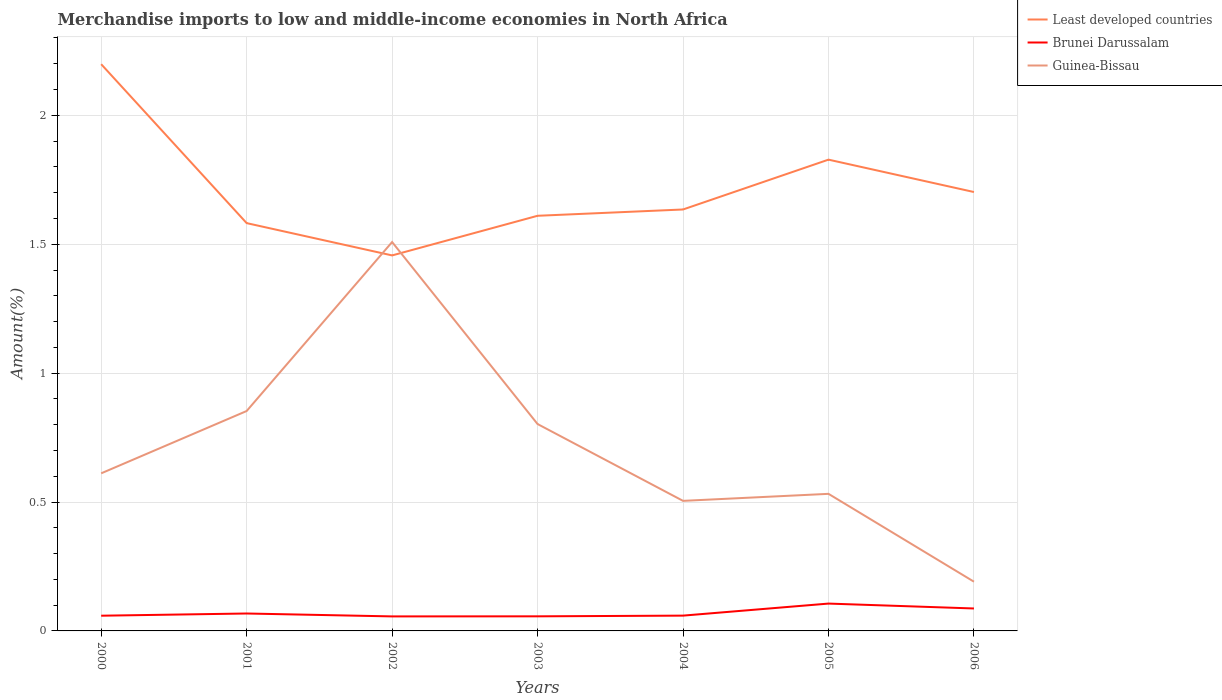Does the line corresponding to Guinea-Bissau intersect with the line corresponding to Least developed countries?
Your answer should be very brief. Yes. Is the number of lines equal to the number of legend labels?
Provide a short and direct response. Yes. Across all years, what is the maximum percentage of amount earned from merchandise imports in Brunei Darussalam?
Offer a terse response. 0.06. What is the total percentage of amount earned from merchandise imports in Brunei Darussalam in the graph?
Provide a succinct answer. 0. What is the difference between the highest and the second highest percentage of amount earned from merchandise imports in Least developed countries?
Your answer should be compact. 0.74. What is the difference between the highest and the lowest percentage of amount earned from merchandise imports in Least developed countries?
Your answer should be very brief. 2. Is the percentage of amount earned from merchandise imports in Brunei Darussalam strictly greater than the percentage of amount earned from merchandise imports in Least developed countries over the years?
Give a very brief answer. Yes. What is the difference between two consecutive major ticks on the Y-axis?
Ensure brevity in your answer.  0.5. Are the values on the major ticks of Y-axis written in scientific E-notation?
Provide a short and direct response. No. Does the graph contain grids?
Provide a succinct answer. Yes. How many legend labels are there?
Provide a succinct answer. 3. How are the legend labels stacked?
Give a very brief answer. Vertical. What is the title of the graph?
Offer a very short reply. Merchandise imports to low and middle-income economies in North Africa. What is the label or title of the Y-axis?
Keep it short and to the point. Amount(%). What is the Amount(%) in Least developed countries in 2000?
Keep it short and to the point. 2.2. What is the Amount(%) in Brunei Darussalam in 2000?
Offer a terse response. 0.06. What is the Amount(%) of Guinea-Bissau in 2000?
Your answer should be very brief. 0.61. What is the Amount(%) of Least developed countries in 2001?
Offer a terse response. 1.58. What is the Amount(%) in Brunei Darussalam in 2001?
Ensure brevity in your answer.  0.07. What is the Amount(%) in Guinea-Bissau in 2001?
Make the answer very short. 0.85. What is the Amount(%) in Least developed countries in 2002?
Provide a short and direct response. 1.46. What is the Amount(%) in Brunei Darussalam in 2002?
Offer a very short reply. 0.06. What is the Amount(%) of Guinea-Bissau in 2002?
Your answer should be compact. 1.51. What is the Amount(%) of Least developed countries in 2003?
Give a very brief answer. 1.61. What is the Amount(%) in Brunei Darussalam in 2003?
Your answer should be very brief. 0.06. What is the Amount(%) of Guinea-Bissau in 2003?
Make the answer very short. 0.8. What is the Amount(%) in Least developed countries in 2004?
Ensure brevity in your answer.  1.63. What is the Amount(%) in Brunei Darussalam in 2004?
Your answer should be compact. 0.06. What is the Amount(%) in Guinea-Bissau in 2004?
Make the answer very short. 0.5. What is the Amount(%) in Least developed countries in 2005?
Offer a very short reply. 1.83. What is the Amount(%) in Brunei Darussalam in 2005?
Ensure brevity in your answer.  0.11. What is the Amount(%) in Guinea-Bissau in 2005?
Ensure brevity in your answer.  0.53. What is the Amount(%) in Least developed countries in 2006?
Offer a very short reply. 1.7. What is the Amount(%) in Brunei Darussalam in 2006?
Make the answer very short. 0.09. What is the Amount(%) of Guinea-Bissau in 2006?
Offer a terse response. 0.19. Across all years, what is the maximum Amount(%) in Least developed countries?
Provide a short and direct response. 2.2. Across all years, what is the maximum Amount(%) of Brunei Darussalam?
Provide a succinct answer. 0.11. Across all years, what is the maximum Amount(%) of Guinea-Bissau?
Provide a short and direct response. 1.51. Across all years, what is the minimum Amount(%) in Least developed countries?
Offer a very short reply. 1.46. Across all years, what is the minimum Amount(%) in Brunei Darussalam?
Keep it short and to the point. 0.06. Across all years, what is the minimum Amount(%) in Guinea-Bissau?
Give a very brief answer. 0.19. What is the total Amount(%) in Least developed countries in the graph?
Offer a terse response. 12.01. What is the total Amount(%) in Brunei Darussalam in the graph?
Your answer should be very brief. 0.49. What is the total Amount(%) in Guinea-Bissau in the graph?
Provide a short and direct response. 5. What is the difference between the Amount(%) in Least developed countries in 2000 and that in 2001?
Your answer should be compact. 0.62. What is the difference between the Amount(%) in Brunei Darussalam in 2000 and that in 2001?
Your answer should be very brief. -0.01. What is the difference between the Amount(%) in Guinea-Bissau in 2000 and that in 2001?
Your answer should be compact. -0.24. What is the difference between the Amount(%) of Least developed countries in 2000 and that in 2002?
Offer a very short reply. 0.74. What is the difference between the Amount(%) of Brunei Darussalam in 2000 and that in 2002?
Provide a succinct answer. 0. What is the difference between the Amount(%) in Guinea-Bissau in 2000 and that in 2002?
Offer a very short reply. -0.9. What is the difference between the Amount(%) of Least developed countries in 2000 and that in 2003?
Provide a short and direct response. 0.59. What is the difference between the Amount(%) of Brunei Darussalam in 2000 and that in 2003?
Your answer should be compact. 0. What is the difference between the Amount(%) of Guinea-Bissau in 2000 and that in 2003?
Give a very brief answer. -0.19. What is the difference between the Amount(%) of Least developed countries in 2000 and that in 2004?
Your answer should be compact. 0.56. What is the difference between the Amount(%) in Brunei Darussalam in 2000 and that in 2004?
Ensure brevity in your answer.  -0. What is the difference between the Amount(%) in Guinea-Bissau in 2000 and that in 2004?
Ensure brevity in your answer.  0.11. What is the difference between the Amount(%) in Least developed countries in 2000 and that in 2005?
Offer a very short reply. 0.37. What is the difference between the Amount(%) in Brunei Darussalam in 2000 and that in 2005?
Make the answer very short. -0.05. What is the difference between the Amount(%) in Guinea-Bissau in 2000 and that in 2005?
Give a very brief answer. 0.08. What is the difference between the Amount(%) of Least developed countries in 2000 and that in 2006?
Keep it short and to the point. 0.5. What is the difference between the Amount(%) of Brunei Darussalam in 2000 and that in 2006?
Provide a short and direct response. -0.03. What is the difference between the Amount(%) in Guinea-Bissau in 2000 and that in 2006?
Your response must be concise. 0.42. What is the difference between the Amount(%) in Least developed countries in 2001 and that in 2002?
Make the answer very short. 0.13. What is the difference between the Amount(%) in Brunei Darussalam in 2001 and that in 2002?
Offer a very short reply. 0.01. What is the difference between the Amount(%) in Guinea-Bissau in 2001 and that in 2002?
Keep it short and to the point. -0.66. What is the difference between the Amount(%) in Least developed countries in 2001 and that in 2003?
Make the answer very short. -0.03. What is the difference between the Amount(%) of Brunei Darussalam in 2001 and that in 2003?
Keep it short and to the point. 0.01. What is the difference between the Amount(%) of Guinea-Bissau in 2001 and that in 2003?
Keep it short and to the point. 0.05. What is the difference between the Amount(%) in Least developed countries in 2001 and that in 2004?
Provide a succinct answer. -0.05. What is the difference between the Amount(%) of Brunei Darussalam in 2001 and that in 2004?
Offer a very short reply. 0.01. What is the difference between the Amount(%) of Guinea-Bissau in 2001 and that in 2004?
Your answer should be compact. 0.35. What is the difference between the Amount(%) in Least developed countries in 2001 and that in 2005?
Ensure brevity in your answer.  -0.25. What is the difference between the Amount(%) in Brunei Darussalam in 2001 and that in 2005?
Your answer should be compact. -0.04. What is the difference between the Amount(%) in Guinea-Bissau in 2001 and that in 2005?
Your answer should be compact. 0.32. What is the difference between the Amount(%) of Least developed countries in 2001 and that in 2006?
Your response must be concise. -0.12. What is the difference between the Amount(%) of Brunei Darussalam in 2001 and that in 2006?
Ensure brevity in your answer.  -0.02. What is the difference between the Amount(%) of Guinea-Bissau in 2001 and that in 2006?
Offer a very short reply. 0.66. What is the difference between the Amount(%) in Least developed countries in 2002 and that in 2003?
Keep it short and to the point. -0.15. What is the difference between the Amount(%) of Brunei Darussalam in 2002 and that in 2003?
Keep it short and to the point. -0. What is the difference between the Amount(%) of Guinea-Bissau in 2002 and that in 2003?
Ensure brevity in your answer.  0.71. What is the difference between the Amount(%) of Least developed countries in 2002 and that in 2004?
Your response must be concise. -0.18. What is the difference between the Amount(%) in Brunei Darussalam in 2002 and that in 2004?
Keep it short and to the point. -0. What is the difference between the Amount(%) in Least developed countries in 2002 and that in 2005?
Offer a terse response. -0.37. What is the difference between the Amount(%) in Brunei Darussalam in 2002 and that in 2005?
Provide a short and direct response. -0.05. What is the difference between the Amount(%) in Guinea-Bissau in 2002 and that in 2005?
Provide a succinct answer. 0.98. What is the difference between the Amount(%) of Least developed countries in 2002 and that in 2006?
Offer a terse response. -0.25. What is the difference between the Amount(%) in Brunei Darussalam in 2002 and that in 2006?
Make the answer very short. -0.03. What is the difference between the Amount(%) of Guinea-Bissau in 2002 and that in 2006?
Provide a short and direct response. 1.32. What is the difference between the Amount(%) in Least developed countries in 2003 and that in 2004?
Offer a terse response. -0.02. What is the difference between the Amount(%) of Brunei Darussalam in 2003 and that in 2004?
Your answer should be very brief. -0. What is the difference between the Amount(%) in Guinea-Bissau in 2003 and that in 2004?
Your answer should be compact. 0.3. What is the difference between the Amount(%) in Least developed countries in 2003 and that in 2005?
Offer a terse response. -0.22. What is the difference between the Amount(%) in Brunei Darussalam in 2003 and that in 2005?
Ensure brevity in your answer.  -0.05. What is the difference between the Amount(%) in Guinea-Bissau in 2003 and that in 2005?
Provide a succinct answer. 0.27. What is the difference between the Amount(%) in Least developed countries in 2003 and that in 2006?
Offer a very short reply. -0.09. What is the difference between the Amount(%) in Brunei Darussalam in 2003 and that in 2006?
Your answer should be compact. -0.03. What is the difference between the Amount(%) in Guinea-Bissau in 2003 and that in 2006?
Provide a short and direct response. 0.61. What is the difference between the Amount(%) in Least developed countries in 2004 and that in 2005?
Keep it short and to the point. -0.19. What is the difference between the Amount(%) in Brunei Darussalam in 2004 and that in 2005?
Provide a short and direct response. -0.05. What is the difference between the Amount(%) in Guinea-Bissau in 2004 and that in 2005?
Keep it short and to the point. -0.03. What is the difference between the Amount(%) of Least developed countries in 2004 and that in 2006?
Make the answer very short. -0.07. What is the difference between the Amount(%) of Brunei Darussalam in 2004 and that in 2006?
Give a very brief answer. -0.03. What is the difference between the Amount(%) of Guinea-Bissau in 2004 and that in 2006?
Offer a terse response. 0.31. What is the difference between the Amount(%) of Least developed countries in 2005 and that in 2006?
Ensure brevity in your answer.  0.13. What is the difference between the Amount(%) of Brunei Darussalam in 2005 and that in 2006?
Provide a succinct answer. 0.02. What is the difference between the Amount(%) in Guinea-Bissau in 2005 and that in 2006?
Your answer should be very brief. 0.34. What is the difference between the Amount(%) in Least developed countries in 2000 and the Amount(%) in Brunei Darussalam in 2001?
Provide a short and direct response. 2.13. What is the difference between the Amount(%) of Least developed countries in 2000 and the Amount(%) of Guinea-Bissau in 2001?
Ensure brevity in your answer.  1.35. What is the difference between the Amount(%) of Brunei Darussalam in 2000 and the Amount(%) of Guinea-Bissau in 2001?
Your answer should be compact. -0.79. What is the difference between the Amount(%) in Least developed countries in 2000 and the Amount(%) in Brunei Darussalam in 2002?
Keep it short and to the point. 2.14. What is the difference between the Amount(%) of Least developed countries in 2000 and the Amount(%) of Guinea-Bissau in 2002?
Give a very brief answer. 0.69. What is the difference between the Amount(%) in Brunei Darussalam in 2000 and the Amount(%) in Guinea-Bissau in 2002?
Your response must be concise. -1.45. What is the difference between the Amount(%) of Least developed countries in 2000 and the Amount(%) of Brunei Darussalam in 2003?
Ensure brevity in your answer.  2.14. What is the difference between the Amount(%) of Least developed countries in 2000 and the Amount(%) of Guinea-Bissau in 2003?
Your answer should be very brief. 1.4. What is the difference between the Amount(%) in Brunei Darussalam in 2000 and the Amount(%) in Guinea-Bissau in 2003?
Keep it short and to the point. -0.74. What is the difference between the Amount(%) of Least developed countries in 2000 and the Amount(%) of Brunei Darussalam in 2004?
Provide a short and direct response. 2.14. What is the difference between the Amount(%) of Least developed countries in 2000 and the Amount(%) of Guinea-Bissau in 2004?
Ensure brevity in your answer.  1.69. What is the difference between the Amount(%) in Brunei Darussalam in 2000 and the Amount(%) in Guinea-Bissau in 2004?
Your response must be concise. -0.45. What is the difference between the Amount(%) in Least developed countries in 2000 and the Amount(%) in Brunei Darussalam in 2005?
Your answer should be very brief. 2.09. What is the difference between the Amount(%) of Least developed countries in 2000 and the Amount(%) of Guinea-Bissau in 2005?
Your answer should be very brief. 1.67. What is the difference between the Amount(%) of Brunei Darussalam in 2000 and the Amount(%) of Guinea-Bissau in 2005?
Offer a very short reply. -0.47. What is the difference between the Amount(%) in Least developed countries in 2000 and the Amount(%) in Brunei Darussalam in 2006?
Provide a succinct answer. 2.11. What is the difference between the Amount(%) of Least developed countries in 2000 and the Amount(%) of Guinea-Bissau in 2006?
Make the answer very short. 2.01. What is the difference between the Amount(%) in Brunei Darussalam in 2000 and the Amount(%) in Guinea-Bissau in 2006?
Keep it short and to the point. -0.13. What is the difference between the Amount(%) in Least developed countries in 2001 and the Amount(%) in Brunei Darussalam in 2002?
Give a very brief answer. 1.53. What is the difference between the Amount(%) in Least developed countries in 2001 and the Amount(%) in Guinea-Bissau in 2002?
Make the answer very short. 0.07. What is the difference between the Amount(%) in Brunei Darussalam in 2001 and the Amount(%) in Guinea-Bissau in 2002?
Offer a terse response. -1.44. What is the difference between the Amount(%) in Least developed countries in 2001 and the Amount(%) in Brunei Darussalam in 2003?
Your response must be concise. 1.53. What is the difference between the Amount(%) of Least developed countries in 2001 and the Amount(%) of Guinea-Bissau in 2003?
Your answer should be compact. 0.78. What is the difference between the Amount(%) in Brunei Darussalam in 2001 and the Amount(%) in Guinea-Bissau in 2003?
Make the answer very short. -0.73. What is the difference between the Amount(%) of Least developed countries in 2001 and the Amount(%) of Brunei Darussalam in 2004?
Offer a very short reply. 1.52. What is the difference between the Amount(%) of Least developed countries in 2001 and the Amount(%) of Guinea-Bissau in 2004?
Your answer should be very brief. 1.08. What is the difference between the Amount(%) of Brunei Darussalam in 2001 and the Amount(%) of Guinea-Bissau in 2004?
Offer a terse response. -0.44. What is the difference between the Amount(%) in Least developed countries in 2001 and the Amount(%) in Brunei Darussalam in 2005?
Your answer should be very brief. 1.48. What is the difference between the Amount(%) of Least developed countries in 2001 and the Amount(%) of Guinea-Bissau in 2005?
Make the answer very short. 1.05. What is the difference between the Amount(%) of Brunei Darussalam in 2001 and the Amount(%) of Guinea-Bissau in 2005?
Make the answer very short. -0.46. What is the difference between the Amount(%) of Least developed countries in 2001 and the Amount(%) of Brunei Darussalam in 2006?
Provide a succinct answer. 1.49. What is the difference between the Amount(%) in Least developed countries in 2001 and the Amount(%) in Guinea-Bissau in 2006?
Ensure brevity in your answer.  1.39. What is the difference between the Amount(%) in Brunei Darussalam in 2001 and the Amount(%) in Guinea-Bissau in 2006?
Your answer should be very brief. -0.12. What is the difference between the Amount(%) in Least developed countries in 2002 and the Amount(%) in Brunei Darussalam in 2003?
Make the answer very short. 1.4. What is the difference between the Amount(%) in Least developed countries in 2002 and the Amount(%) in Guinea-Bissau in 2003?
Ensure brevity in your answer.  0.65. What is the difference between the Amount(%) in Brunei Darussalam in 2002 and the Amount(%) in Guinea-Bissau in 2003?
Your answer should be compact. -0.75. What is the difference between the Amount(%) of Least developed countries in 2002 and the Amount(%) of Brunei Darussalam in 2004?
Your response must be concise. 1.4. What is the difference between the Amount(%) of Least developed countries in 2002 and the Amount(%) of Guinea-Bissau in 2004?
Your answer should be very brief. 0.95. What is the difference between the Amount(%) of Brunei Darussalam in 2002 and the Amount(%) of Guinea-Bissau in 2004?
Your answer should be very brief. -0.45. What is the difference between the Amount(%) of Least developed countries in 2002 and the Amount(%) of Brunei Darussalam in 2005?
Provide a short and direct response. 1.35. What is the difference between the Amount(%) of Least developed countries in 2002 and the Amount(%) of Guinea-Bissau in 2005?
Provide a succinct answer. 0.92. What is the difference between the Amount(%) of Brunei Darussalam in 2002 and the Amount(%) of Guinea-Bissau in 2005?
Give a very brief answer. -0.48. What is the difference between the Amount(%) of Least developed countries in 2002 and the Amount(%) of Brunei Darussalam in 2006?
Offer a terse response. 1.37. What is the difference between the Amount(%) in Least developed countries in 2002 and the Amount(%) in Guinea-Bissau in 2006?
Make the answer very short. 1.27. What is the difference between the Amount(%) in Brunei Darussalam in 2002 and the Amount(%) in Guinea-Bissau in 2006?
Offer a very short reply. -0.13. What is the difference between the Amount(%) in Least developed countries in 2003 and the Amount(%) in Brunei Darussalam in 2004?
Your answer should be compact. 1.55. What is the difference between the Amount(%) of Least developed countries in 2003 and the Amount(%) of Guinea-Bissau in 2004?
Keep it short and to the point. 1.11. What is the difference between the Amount(%) of Brunei Darussalam in 2003 and the Amount(%) of Guinea-Bissau in 2004?
Keep it short and to the point. -0.45. What is the difference between the Amount(%) in Least developed countries in 2003 and the Amount(%) in Brunei Darussalam in 2005?
Your answer should be very brief. 1.5. What is the difference between the Amount(%) in Least developed countries in 2003 and the Amount(%) in Guinea-Bissau in 2005?
Ensure brevity in your answer.  1.08. What is the difference between the Amount(%) in Brunei Darussalam in 2003 and the Amount(%) in Guinea-Bissau in 2005?
Offer a terse response. -0.48. What is the difference between the Amount(%) in Least developed countries in 2003 and the Amount(%) in Brunei Darussalam in 2006?
Your answer should be very brief. 1.52. What is the difference between the Amount(%) in Least developed countries in 2003 and the Amount(%) in Guinea-Bissau in 2006?
Make the answer very short. 1.42. What is the difference between the Amount(%) in Brunei Darussalam in 2003 and the Amount(%) in Guinea-Bissau in 2006?
Offer a terse response. -0.13. What is the difference between the Amount(%) in Least developed countries in 2004 and the Amount(%) in Brunei Darussalam in 2005?
Offer a terse response. 1.53. What is the difference between the Amount(%) in Least developed countries in 2004 and the Amount(%) in Guinea-Bissau in 2005?
Your answer should be compact. 1.1. What is the difference between the Amount(%) of Brunei Darussalam in 2004 and the Amount(%) of Guinea-Bissau in 2005?
Make the answer very short. -0.47. What is the difference between the Amount(%) of Least developed countries in 2004 and the Amount(%) of Brunei Darussalam in 2006?
Offer a very short reply. 1.55. What is the difference between the Amount(%) in Least developed countries in 2004 and the Amount(%) in Guinea-Bissau in 2006?
Your response must be concise. 1.44. What is the difference between the Amount(%) of Brunei Darussalam in 2004 and the Amount(%) of Guinea-Bissau in 2006?
Provide a short and direct response. -0.13. What is the difference between the Amount(%) of Least developed countries in 2005 and the Amount(%) of Brunei Darussalam in 2006?
Make the answer very short. 1.74. What is the difference between the Amount(%) in Least developed countries in 2005 and the Amount(%) in Guinea-Bissau in 2006?
Offer a terse response. 1.64. What is the difference between the Amount(%) of Brunei Darussalam in 2005 and the Amount(%) of Guinea-Bissau in 2006?
Your answer should be very brief. -0.08. What is the average Amount(%) in Least developed countries per year?
Your response must be concise. 1.72. What is the average Amount(%) in Brunei Darussalam per year?
Provide a short and direct response. 0.07. What is the average Amount(%) in Guinea-Bissau per year?
Make the answer very short. 0.71. In the year 2000, what is the difference between the Amount(%) in Least developed countries and Amount(%) in Brunei Darussalam?
Make the answer very short. 2.14. In the year 2000, what is the difference between the Amount(%) of Least developed countries and Amount(%) of Guinea-Bissau?
Your response must be concise. 1.59. In the year 2000, what is the difference between the Amount(%) of Brunei Darussalam and Amount(%) of Guinea-Bissau?
Provide a short and direct response. -0.55. In the year 2001, what is the difference between the Amount(%) of Least developed countries and Amount(%) of Brunei Darussalam?
Provide a short and direct response. 1.51. In the year 2001, what is the difference between the Amount(%) in Least developed countries and Amount(%) in Guinea-Bissau?
Ensure brevity in your answer.  0.73. In the year 2001, what is the difference between the Amount(%) in Brunei Darussalam and Amount(%) in Guinea-Bissau?
Keep it short and to the point. -0.79. In the year 2002, what is the difference between the Amount(%) in Least developed countries and Amount(%) in Brunei Darussalam?
Ensure brevity in your answer.  1.4. In the year 2002, what is the difference between the Amount(%) in Least developed countries and Amount(%) in Guinea-Bissau?
Ensure brevity in your answer.  -0.05. In the year 2002, what is the difference between the Amount(%) of Brunei Darussalam and Amount(%) of Guinea-Bissau?
Your answer should be very brief. -1.45. In the year 2003, what is the difference between the Amount(%) of Least developed countries and Amount(%) of Brunei Darussalam?
Give a very brief answer. 1.55. In the year 2003, what is the difference between the Amount(%) in Least developed countries and Amount(%) in Guinea-Bissau?
Make the answer very short. 0.81. In the year 2003, what is the difference between the Amount(%) of Brunei Darussalam and Amount(%) of Guinea-Bissau?
Ensure brevity in your answer.  -0.75. In the year 2004, what is the difference between the Amount(%) in Least developed countries and Amount(%) in Brunei Darussalam?
Your response must be concise. 1.58. In the year 2004, what is the difference between the Amount(%) of Least developed countries and Amount(%) of Guinea-Bissau?
Give a very brief answer. 1.13. In the year 2004, what is the difference between the Amount(%) of Brunei Darussalam and Amount(%) of Guinea-Bissau?
Offer a very short reply. -0.45. In the year 2005, what is the difference between the Amount(%) in Least developed countries and Amount(%) in Brunei Darussalam?
Provide a short and direct response. 1.72. In the year 2005, what is the difference between the Amount(%) in Least developed countries and Amount(%) in Guinea-Bissau?
Your answer should be very brief. 1.3. In the year 2005, what is the difference between the Amount(%) of Brunei Darussalam and Amount(%) of Guinea-Bissau?
Offer a very short reply. -0.43. In the year 2006, what is the difference between the Amount(%) in Least developed countries and Amount(%) in Brunei Darussalam?
Give a very brief answer. 1.62. In the year 2006, what is the difference between the Amount(%) in Least developed countries and Amount(%) in Guinea-Bissau?
Your answer should be very brief. 1.51. In the year 2006, what is the difference between the Amount(%) of Brunei Darussalam and Amount(%) of Guinea-Bissau?
Ensure brevity in your answer.  -0.1. What is the ratio of the Amount(%) in Least developed countries in 2000 to that in 2001?
Give a very brief answer. 1.39. What is the ratio of the Amount(%) of Brunei Darussalam in 2000 to that in 2001?
Offer a terse response. 0.87. What is the ratio of the Amount(%) in Guinea-Bissau in 2000 to that in 2001?
Your response must be concise. 0.72. What is the ratio of the Amount(%) of Least developed countries in 2000 to that in 2002?
Ensure brevity in your answer.  1.51. What is the ratio of the Amount(%) in Brunei Darussalam in 2000 to that in 2002?
Your answer should be compact. 1.05. What is the ratio of the Amount(%) in Guinea-Bissau in 2000 to that in 2002?
Your answer should be very brief. 0.41. What is the ratio of the Amount(%) in Least developed countries in 2000 to that in 2003?
Your answer should be very brief. 1.37. What is the ratio of the Amount(%) in Brunei Darussalam in 2000 to that in 2003?
Provide a succinct answer. 1.04. What is the ratio of the Amount(%) of Guinea-Bissau in 2000 to that in 2003?
Ensure brevity in your answer.  0.76. What is the ratio of the Amount(%) in Least developed countries in 2000 to that in 2004?
Your answer should be very brief. 1.34. What is the ratio of the Amount(%) in Guinea-Bissau in 2000 to that in 2004?
Keep it short and to the point. 1.21. What is the ratio of the Amount(%) of Least developed countries in 2000 to that in 2005?
Offer a very short reply. 1.2. What is the ratio of the Amount(%) of Brunei Darussalam in 2000 to that in 2005?
Your answer should be compact. 0.56. What is the ratio of the Amount(%) in Guinea-Bissau in 2000 to that in 2005?
Give a very brief answer. 1.15. What is the ratio of the Amount(%) of Least developed countries in 2000 to that in 2006?
Ensure brevity in your answer.  1.29. What is the ratio of the Amount(%) in Brunei Darussalam in 2000 to that in 2006?
Offer a terse response. 0.68. What is the ratio of the Amount(%) in Guinea-Bissau in 2000 to that in 2006?
Your answer should be very brief. 3.2. What is the ratio of the Amount(%) of Least developed countries in 2001 to that in 2002?
Ensure brevity in your answer.  1.09. What is the ratio of the Amount(%) of Brunei Darussalam in 2001 to that in 2002?
Ensure brevity in your answer.  1.2. What is the ratio of the Amount(%) in Guinea-Bissau in 2001 to that in 2002?
Provide a short and direct response. 0.57. What is the ratio of the Amount(%) in Least developed countries in 2001 to that in 2003?
Give a very brief answer. 0.98. What is the ratio of the Amount(%) of Brunei Darussalam in 2001 to that in 2003?
Provide a succinct answer. 1.19. What is the ratio of the Amount(%) of Guinea-Bissau in 2001 to that in 2003?
Provide a short and direct response. 1.06. What is the ratio of the Amount(%) in Least developed countries in 2001 to that in 2004?
Keep it short and to the point. 0.97. What is the ratio of the Amount(%) in Brunei Darussalam in 2001 to that in 2004?
Offer a terse response. 1.14. What is the ratio of the Amount(%) of Guinea-Bissau in 2001 to that in 2004?
Offer a very short reply. 1.69. What is the ratio of the Amount(%) of Least developed countries in 2001 to that in 2005?
Offer a terse response. 0.87. What is the ratio of the Amount(%) in Brunei Darussalam in 2001 to that in 2005?
Offer a terse response. 0.64. What is the ratio of the Amount(%) of Guinea-Bissau in 2001 to that in 2005?
Ensure brevity in your answer.  1.6. What is the ratio of the Amount(%) of Least developed countries in 2001 to that in 2006?
Give a very brief answer. 0.93. What is the ratio of the Amount(%) of Brunei Darussalam in 2001 to that in 2006?
Give a very brief answer. 0.78. What is the ratio of the Amount(%) in Guinea-Bissau in 2001 to that in 2006?
Your answer should be compact. 4.47. What is the ratio of the Amount(%) of Least developed countries in 2002 to that in 2003?
Keep it short and to the point. 0.9. What is the ratio of the Amount(%) of Brunei Darussalam in 2002 to that in 2003?
Your answer should be compact. 0.99. What is the ratio of the Amount(%) in Guinea-Bissau in 2002 to that in 2003?
Offer a terse response. 1.88. What is the ratio of the Amount(%) in Least developed countries in 2002 to that in 2004?
Make the answer very short. 0.89. What is the ratio of the Amount(%) of Brunei Darussalam in 2002 to that in 2004?
Ensure brevity in your answer.  0.95. What is the ratio of the Amount(%) in Guinea-Bissau in 2002 to that in 2004?
Give a very brief answer. 2.99. What is the ratio of the Amount(%) in Least developed countries in 2002 to that in 2005?
Make the answer very short. 0.8. What is the ratio of the Amount(%) of Brunei Darussalam in 2002 to that in 2005?
Provide a succinct answer. 0.53. What is the ratio of the Amount(%) of Guinea-Bissau in 2002 to that in 2005?
Ensure brevity in your answer.  2.84. What is the ratio of the Amount(%) in Least developed countries in 2002 to that in 2006?
Your response must be concise. 0.86. What is the ratio of the Amount(%) in Brunei Darussalam in 2002 to that in 2006?
Your response must be concise. 0.65. What is the ratio of the Amount(%) in Guinea-Bissau in 2002 to that in 2006?
Your response must be concise. 7.9. What is the ratio of the Amount(%) in Brunei Darussalam in 2003 to that in 2004?
Your answer should be very brief. 0.95. What is the ratio of the Amount(%) in Guinea-Bissau in 2003 to that in 2004?
Provide a succinct answer. 1.59. What is the ratio of the Amount(%) of Least developed countries in 2003 to that in 2005?
Provide a succinct answer. 0.88. What is the ratio of the Amount(%) of Brunei Darussalam in 2003 to that in 2005?
Make the answer very short. 0.53. What is the ratio of the Amount(%) in Guinea-Bissau in 2003 to that in 2005?
Make the answer very short. 1.51. What is the ratio of the Amount(%) of Least developed countries in 2003 to that in 2006?
Make the answer very short. 0.95. What is the ratio of the Amount(%) in Brunei Darussalam in 2003 to that in 2006?
Provide a succinct answer. 0.65. What is the ratio of the Amount(%) of Guinea-Bissau in 2003 to that in 2006?
Keep it short and to the point. 4.2. What is the ratio of the Amount(%) in Least developed countries in 2004 to that in 2005?
Give a very brief answer. 0.89. What is the ratio of the Amount(%) of Brunei Darussalam in 2004 to that in 2005?
Your answer should be compact. 0.56. What is the ratio of the Amount(%) of Guinea-Bissau in 2004 to that in 2005?
Keep it short and to the point. 0.95. What is the ratio of the Amount(%) of Least developed countries in 2004 to that in 2006?
Offer a terse response. 0.96. What is the ratio of the Amount(%) in Brunei Darussalam in 2004 to that in 2006?
Provide a succinct answer. 0.68. What is the ratio of the Amount(%) of Guinea-Bissau in 2004 to that in 2006?
Provide a short and direct response. 2.64. What is the ratio of the Amount(%) of Least developed countries in 2005 to that in 2006?
Make the answer very short. 1.07. What is the ratio of the Amount(%) of Brunei Darussalam in 2005 to that in 2006?
Your answer should be compact. 1.22. What is the ratio of the Amount(%) of Guinea-Bissau in 2005 to that in 2006?
Your answer should be very brief. 2.78. What is the difference between the highest and the second highest Amount(%) in Least developed countries?
Your answer should be very brief. 0.37. What is the difference between the highest and the second highest Amount(%) of Brunei Darussalam?
Give a very brief answer. 0.02. What is the difference between the highest and the second highest Amount(%) in Guinea-Bissau?
Offer a very short reply. 0.66. What is the difference between the highest and the lowest Amount(%) in Least developed countries?
Provide a short and direct response. 0.74. What is the difference between the highest and the lowest Amount(%) in Brunei Darussalam?
Your answer should be very brief. 0.05. What is the difference between the highest and the lowest Amount(%) of Guinea-Bissau?
Keep it short and to the point. 1.32. 